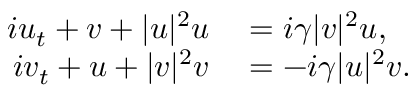Convert formula to latex. <formula><loc_0><loc_0><loc_500><loc_500>\begin{array} { r l } { i u _ { t } + v + | u | ^ { 2 } u } & = i \gamma | v | ^ { 2 } u , } \\ { i v _ { t } + u + | v | ^ { 2 } v } & = - i \gamma | u | ^ { 2 } v . } \end{array}</formula> 